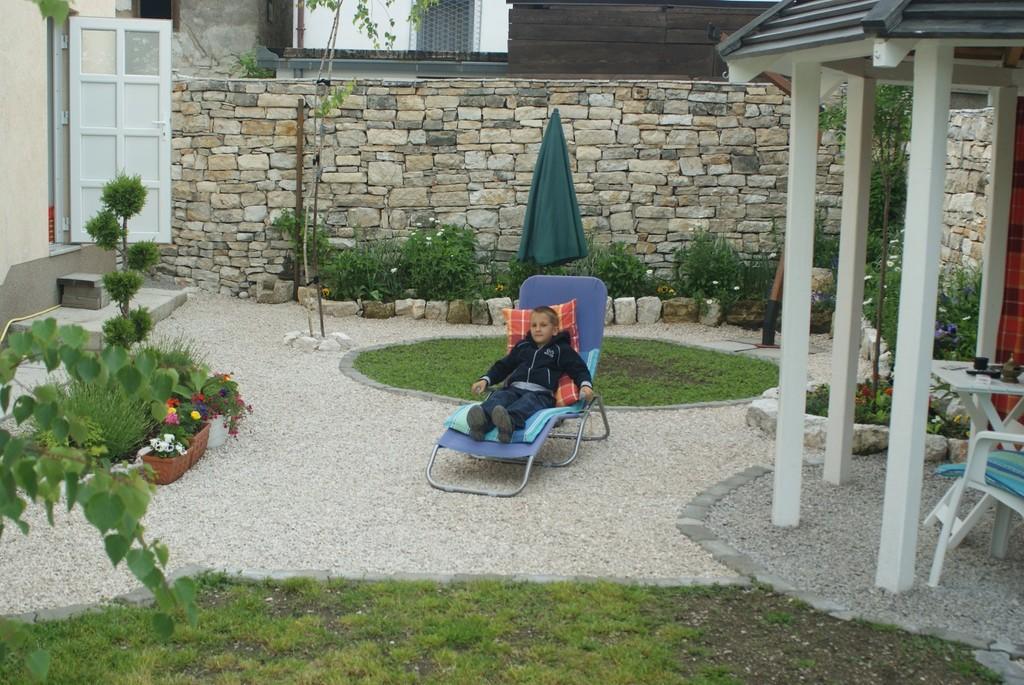Can you describe this image briefly? This is an outside view. In the middle of the image there is a boy sitting on the chair. In the background there is a wall and some plants. On the right side of the image there is a shed under that there is a table and one chair. On the left side of the image I can see a flower pot. 